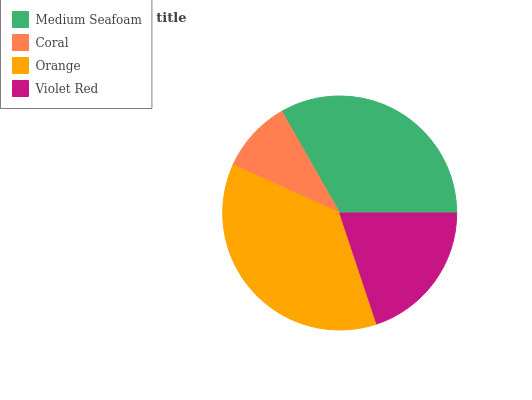Is Coral the minimum?
Answer yes or no. Yes. Is Orange the maximum?
Answer yes or no. Yes. Is Orange the minimum?
Answer yes or no. No. Is Coral the maximum?
Answer yes or no. No. Is Orange greater than Coral?
Answer yes or no. Yes. Is Coral less than Orange?
Answer yes or no. Yes. Is Coral greater than Orange?
Answer yes or no. No. Is Orange less than Coral?
Answer yes or no. No. Is Medium Seafoam the high median?
Answer yes or no. Yes. Is Violet Red the low median?
Answer yes or no. Yes. Is Violet Red the high median?
Answer yes or no. No. Is Orange the low median?
Answer yes or no. No. 